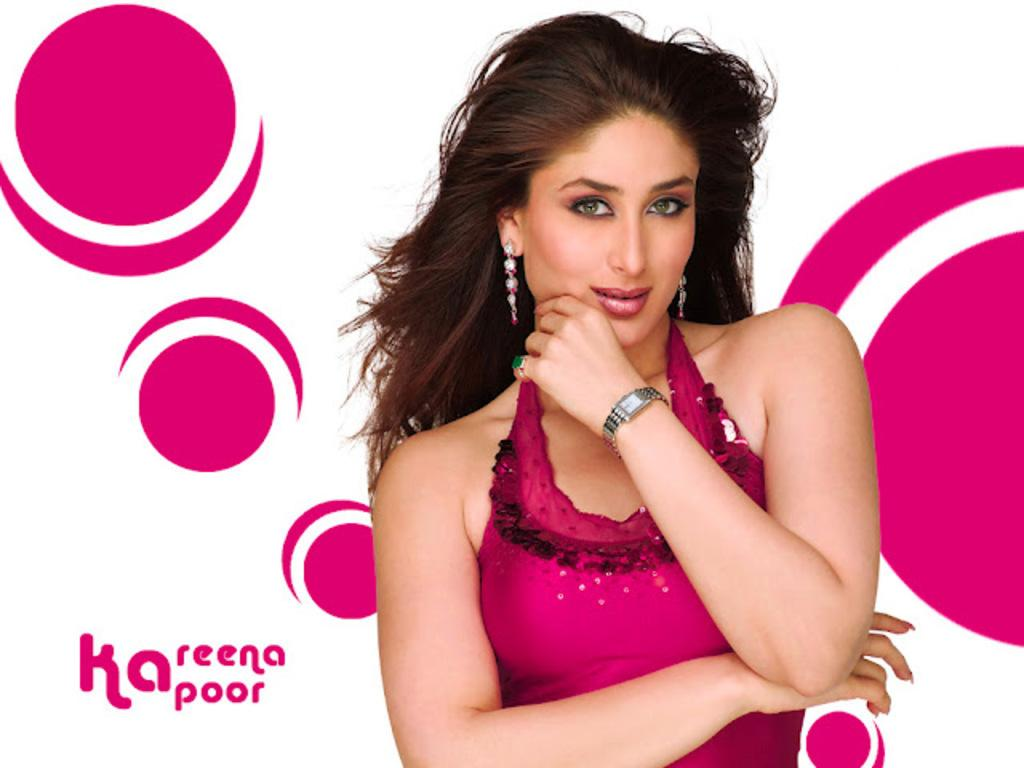Who is the main subject in the image? There is a woman in the center of the image. What else can be seen in the image besides the woman? There is text in the bottom left corner of the image. What type of pan is being used by the women in the image? There are no women or pans present in the image; it only features a woman and text. 